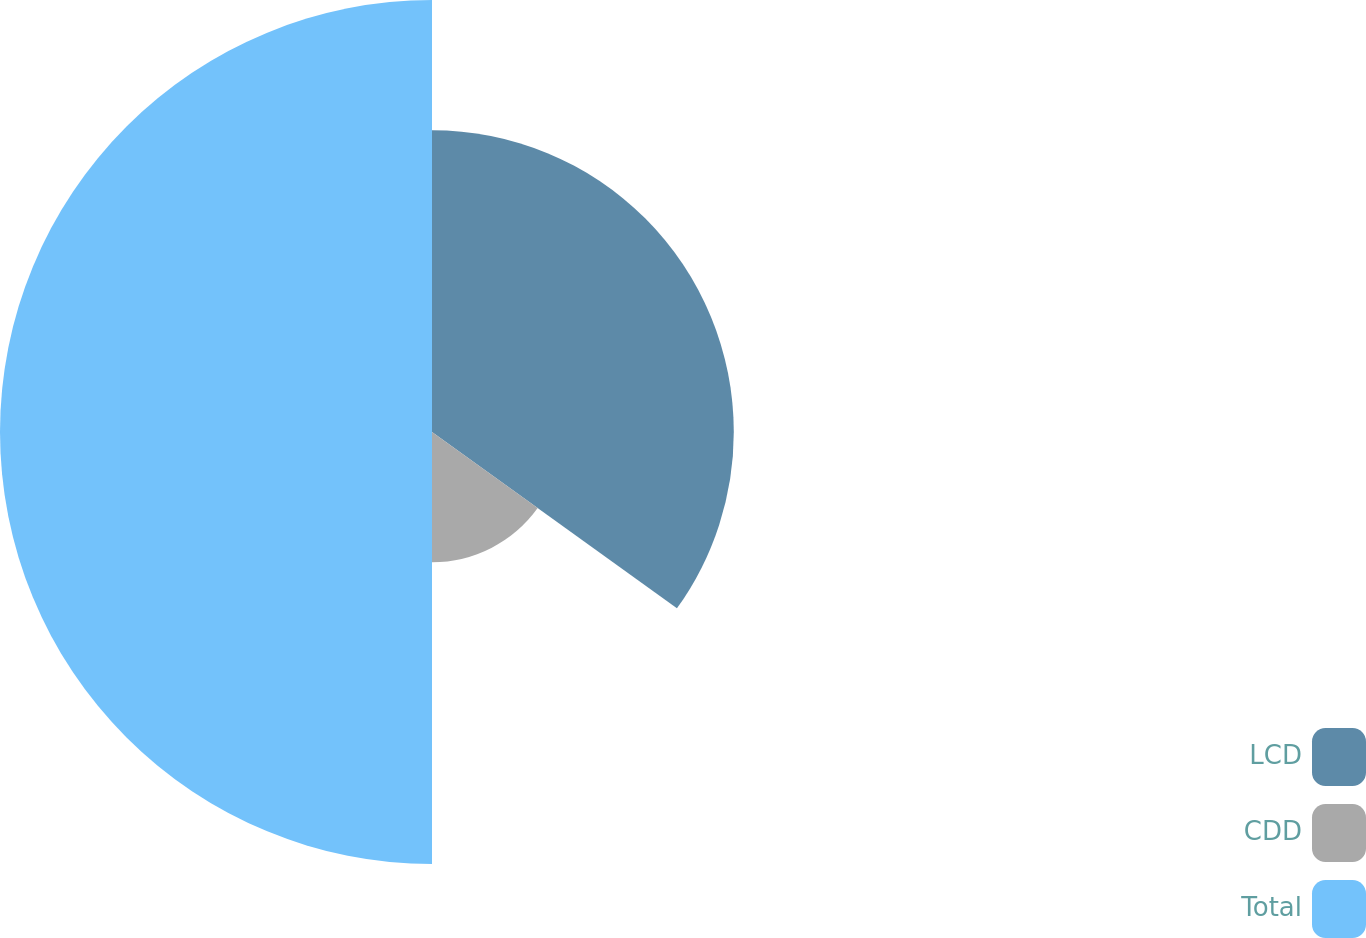Convert chart. <chart><loc_0><loc_0><loc_500><loc_500><pie_chart><fcel>LCD<fcel>CDD<fcel>Total<nl><fcel>34.93%<fcel>15.07%<fcel>50.0%<nl></chart> 